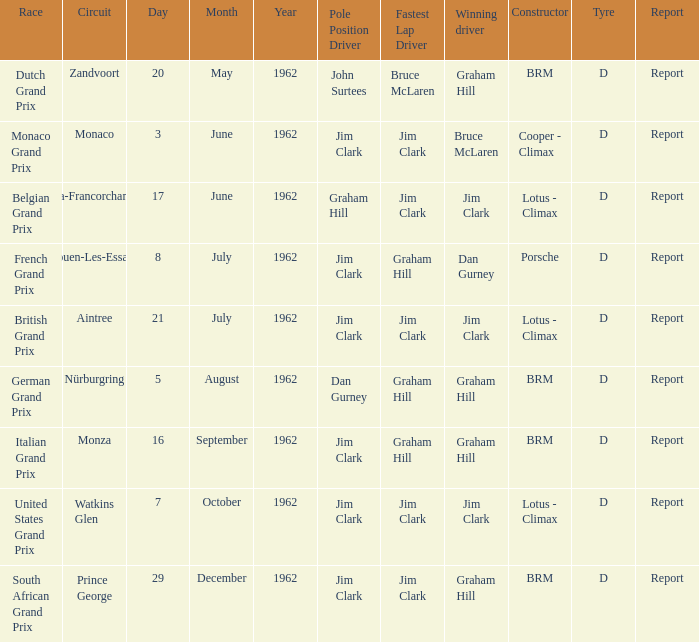What is the constructor at the United States Grand Prix? Lotus - Climax. 